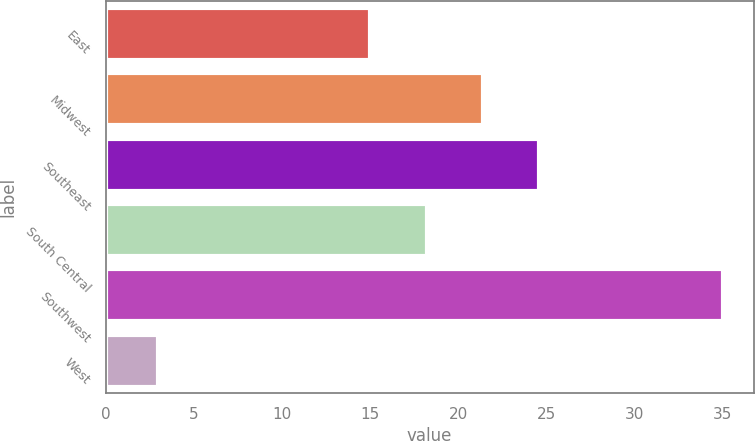<chart> <loc_0><loc_0><loc_500><loc_500><bar_chart><fcel>East<fcel>Midwest<fcel>Southeast<fcel>South Central<fcel>Southwest<fcel>West<nl><fcel>15<fcel>21.4<fcel>24.6<fcel>18.2<fcel>35<fcel>3<nl></chart> 